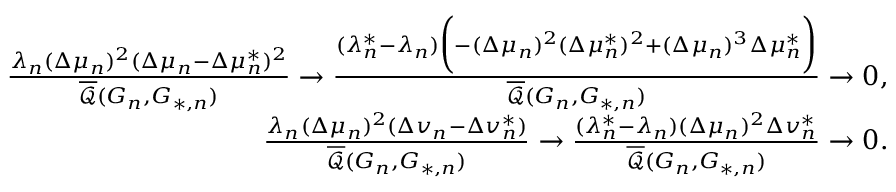<formula> <loc_0><loc_0><loc_500><loc_500>\begin{array} { r l r } & { \frac { \lambda _ { n } ( \Delta \mu _ { n } ) ^ { 2 } ( \Delta \mu _ { n } - \Delta \mu _ { n } ^ { * } ) ^ { 2 } } { \overline { { \mathcal { Q } } } ( G _ { n } , G _ { * , n } ) } \to \frac { ( \lambda _ { n } ^ { * } - \lambda _ { n } ) \left ( - ( \Delta \mu _ { n } ) ^ { 2 } ( \Delta \mu _ { n } ^ { * } ) ^ { 2 } + ( \Delta \mu _ { n } ) ^ { 3 } \Delta \mu _ { n } ^ { * } \right ) } { \overline { { \mathcal { Q } } } ( G _ { n } , G _ { * , n } ) } \to 0 , } \\ & { \frac { \lambda _ { n } ( \Delta \mu _ { n } ) ^ { 2 } ( \Delta v _ { n } - \Delta v _ { n } ^ { * } ) } { \overline { { \mathcal { Q } } } ( G _ { n } , G _ { * , n } ) } \to \frac { ( \lambda _ { n } ^ { * } - \lambda _ { n } ) ( \Delta \mu _ { n } ) ^ { 2 } \Delta v _ { n } ^ { * } } { \overline { { \mathcal { Q } } } ( G _ { n } , G _ { * , n } ) } \to 0 . } \end{array}</formula> 